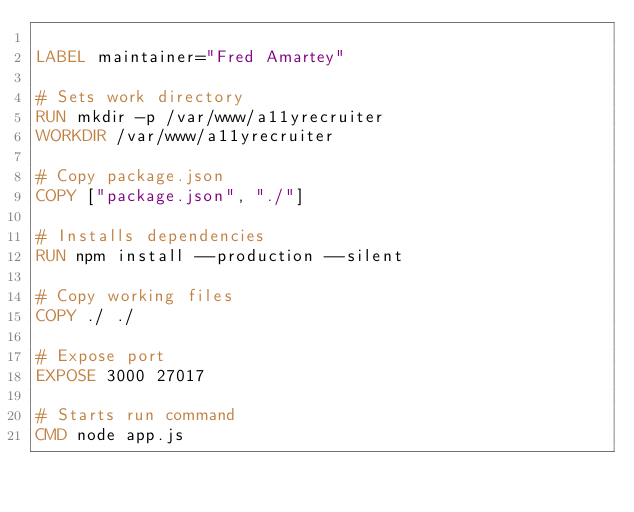Convert code to text. <code><loc_0><loc_0><loc_500><loc_500><_Dockerfile_>
LABEL maintainer="Fred Amartey"

# Sets work directory
RUN mkdir -p /var/www/a11yrecruiter
WORKDIR /var/www/a11yrecruiter

# Copy package.json
COPY ["package.json", "./"]

# Installs dependencies 
RUN npm install --production --silent

# Copy working files
COPY ./ ./

# Expose port
EXPOSE 3000 27017

# Starts run command
CMD node app.js</code> 